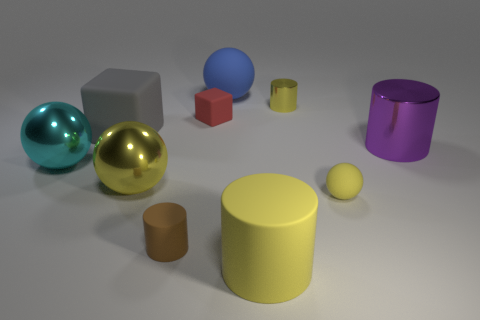What number of blue rubber things are the same shape as the big cyan object?
Make the answer very short. 1. What is the material of the yellow ball that is the same size as the red block?
Your answer should be very brief. Rubber. Is there a yellow cylinder that has the same material as the blue sphere?
Your response must be concise. Yes. Is the number of big cyan metal balls to the right of the tiny red cube less than the number of large shiny cylinders?
Keep it short and to the point. Yes. What material is the big cylinder to the left of the big shiny object right of the blue object?
Keep it short and to the point. Rubber. There is a small object that is both behind the brown rubber cylinder and on the left side of the blue sphere; what is its shape?
Offer a terse response. Cube. How many other things are there of the same color as the tiny metal thing?
Provide a succinct answer. 3. How many things are either cyan shiny objects that are on the left side of the yellow shiny ball or large cyan blocks?
Provide a succinct answer. 1. There is a tiny metallic object; does it have the same color as the object that is to the right of the tiny ball?
Keep it short and to the point. No. Are there any other things that are the same size as the purple thing?
Provide a succinct answer. Yes. 